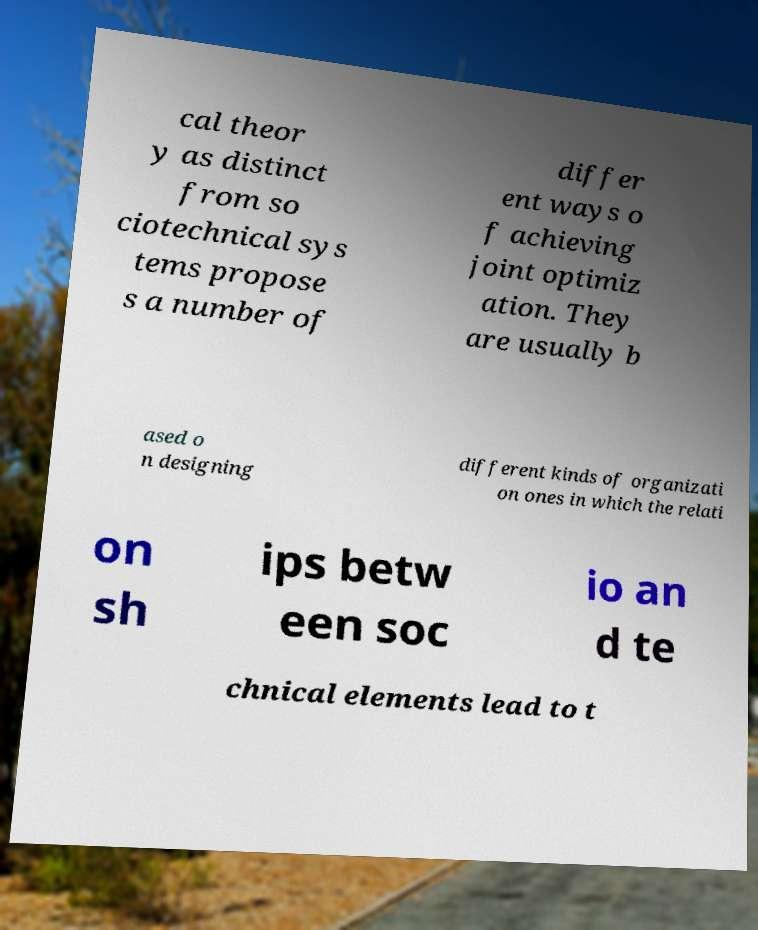Can you accurately transcribe the text from the provided image for me? cal theor y as distinct from so ciotechnical sys tems propose s a number of differ ent ways o f achieving joint optimiz ation. They are usually b ased o n designing different kinds of organizati on ones in which the relati on sh ips betw een soc io an d te chnical elements lead to t 